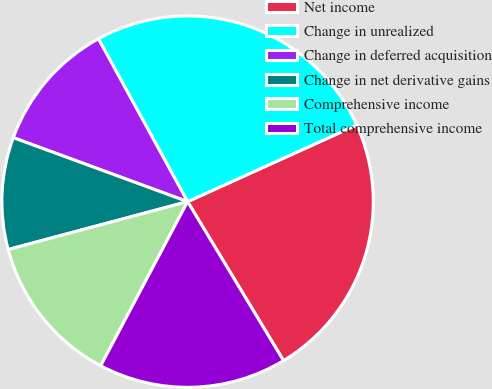<chart> <loc_0><loc_0><loc_500><loc_500><pie_chart><fcel>Net income<fcel>Change in unrealized<fcel>Change in deferred acquisition<fcel>Change in net derivative gains<fcel>Comprehensive income<fcel>Total comprehensive income<nl><fcel>23.13%<fcel>26.2%<fcel>11.43%<fcel>9.75%<fcel>13.1%<fcel>16.39%<nl></chart> 